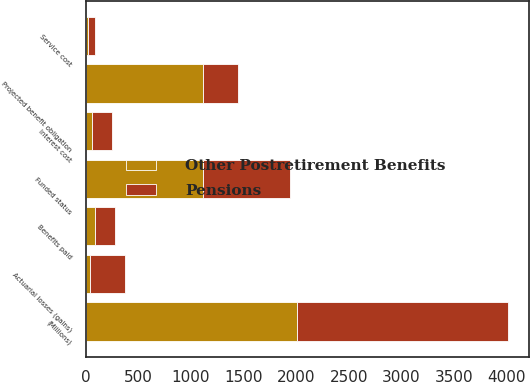Convert chart to OTSL. <chart><loc_0><loc_0><loc_500><loc_500><stacked_bar_chart><ecel><fcel>(Millions)<fcel>Projected benefit obligation<fcel>Service cost<fcel>Interest cost<fcel>Actuarial losses (gains)<fcel>Benefits paid<fcel>Funded status<nl><fcel>Pensions<fcel>2005<fcel>330<fcel>64<fcel>189<fcel>330<fcel>196<fcel>824<nl><fcel>Other Postretirement Benefits<fcel>2005<fcel>1119<fcel>24<fcel>63<fcel>41<fcel>83<fcel>1119<nl></chart> 